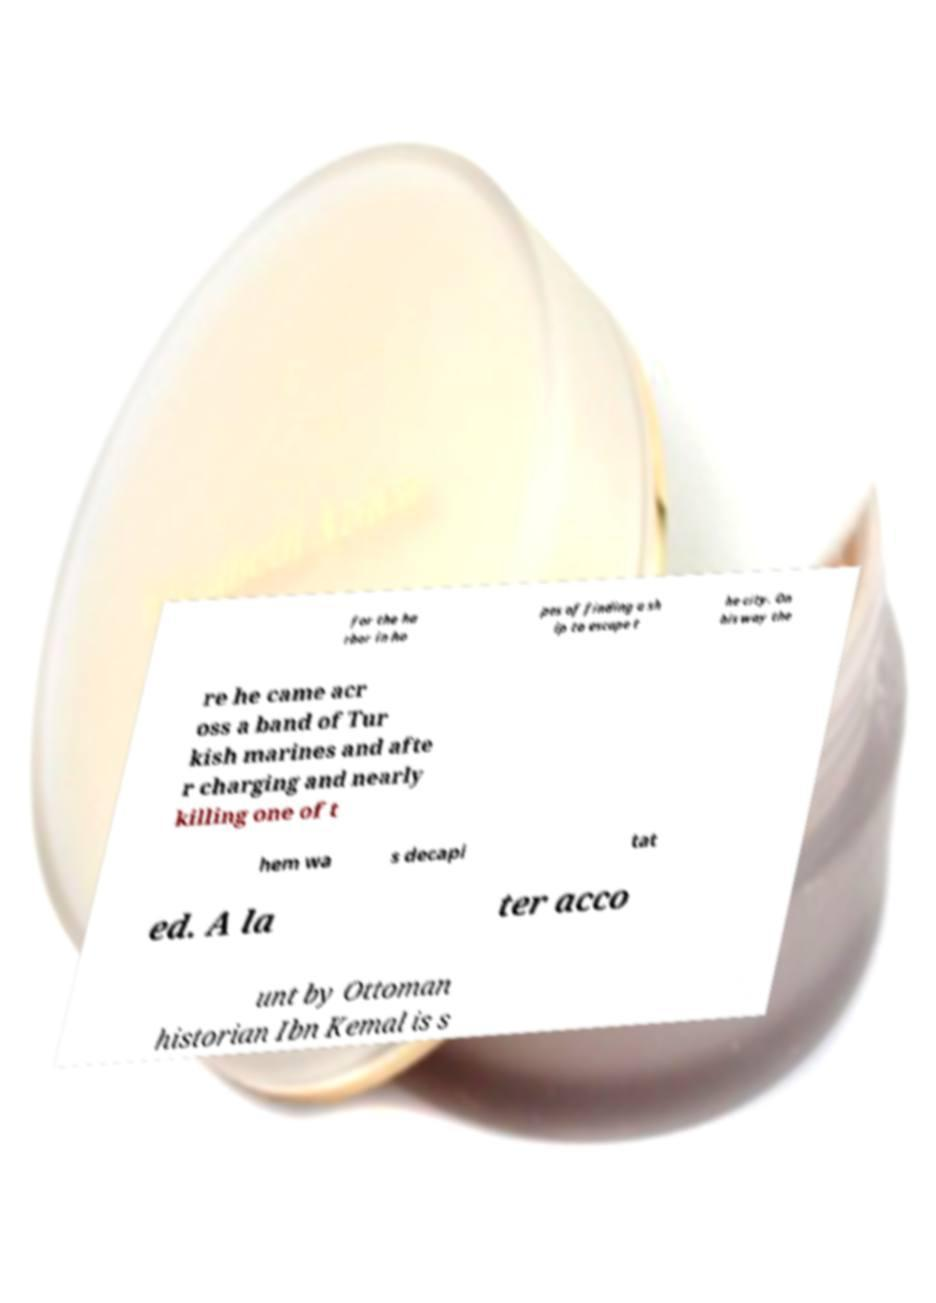Could you extract and type out the text from this image? for the ha rbor in ho pes of finding a sh ip to escape t he city. On his way the re he came acr oss a band of Tur kish marines and afte r charging and nearly killing one of t hem wa s decapi tat ed. A la ter acco unt by Ottoman historian Ibn Kemal is s 